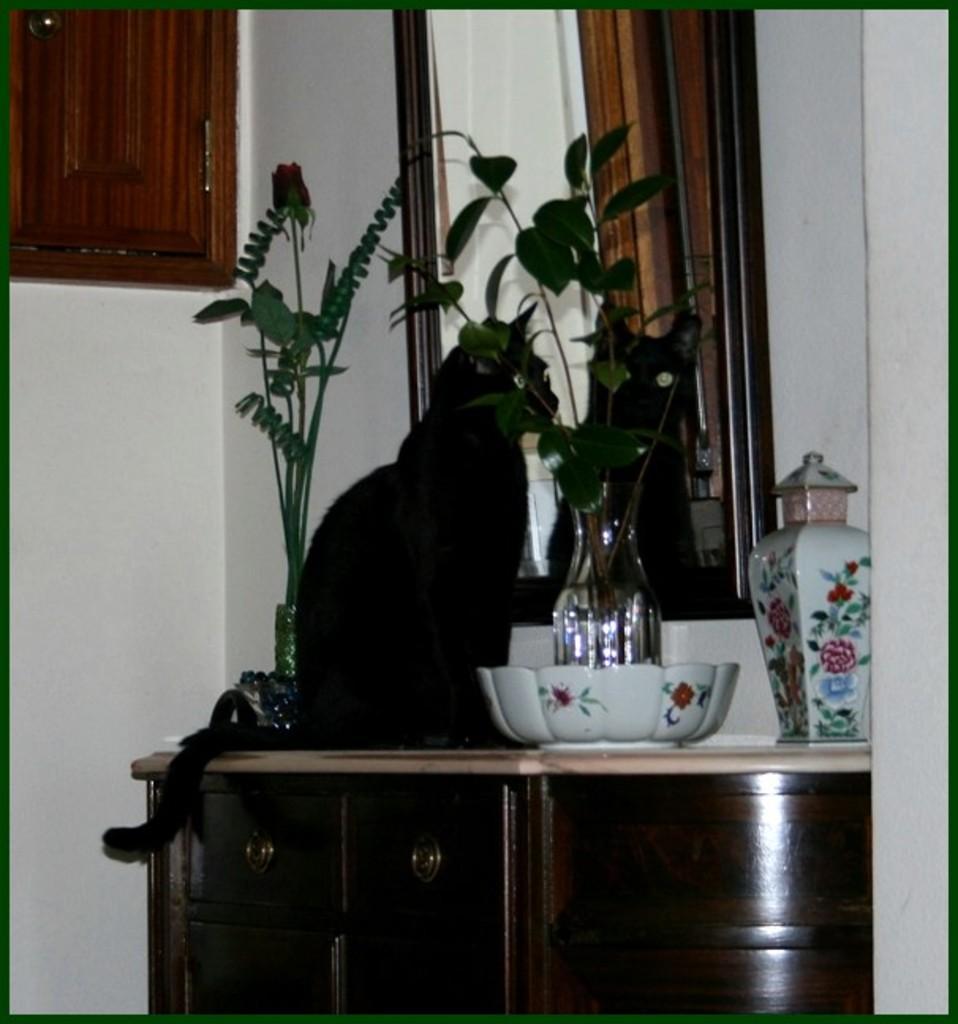Could you give a brief overview of what you see in this image? This is a picture taken in a room, this is a table on the table there are jar, bowl glass bottle with plant and a black cat. Behind the cat there is a mirror and a wall and a wooden shelf. 